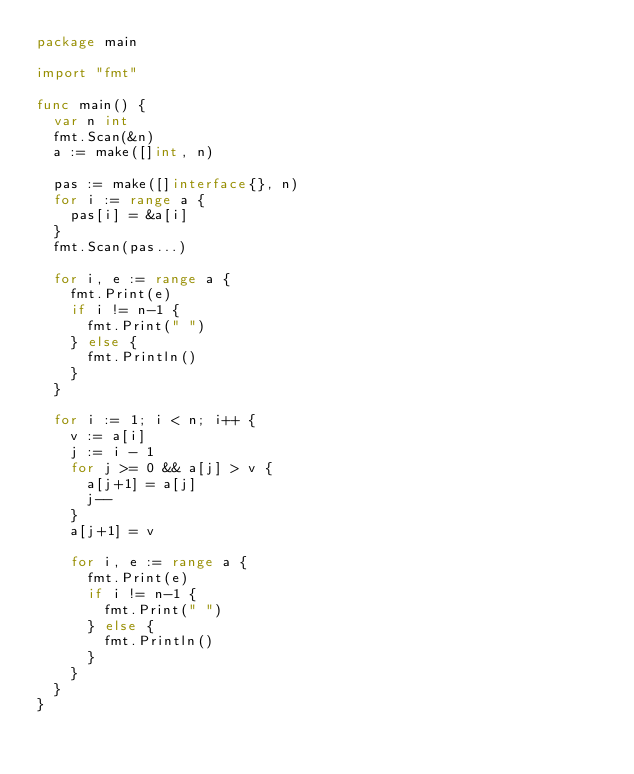Convert code to text. <code><loc_0><loc_0><loc_500><loc_500><_Go_>package main

import "fmt"

func main() {
	var n int
	fmt.Scan(&n)
	a := make([]int, n)

	pas := make([]interface{}, n)
	for i := range a {
		pas[i] = &a[i]
	}
	fmt.Scan(pas...)

	for i, e := range a {
		fmt.Print(e)
		if i != n-1 {
			fmt.Print(" ")
		} else {
			fmt.Println()
		}
	}

	for i := 1; i < n; i++ {
		v := a[i]
		j := i - 1
		for j >= 0 && a[j] > v {
			a[j+1] = a[j]
			j--
		}
		a[j+1] = v

		for i, e := range a {
			fmt.Print(e)
			if i != n-1 {
				fmt.Print(" ")
			} else {
				fmt.Println()
			}
		}
	}
}

</code> 